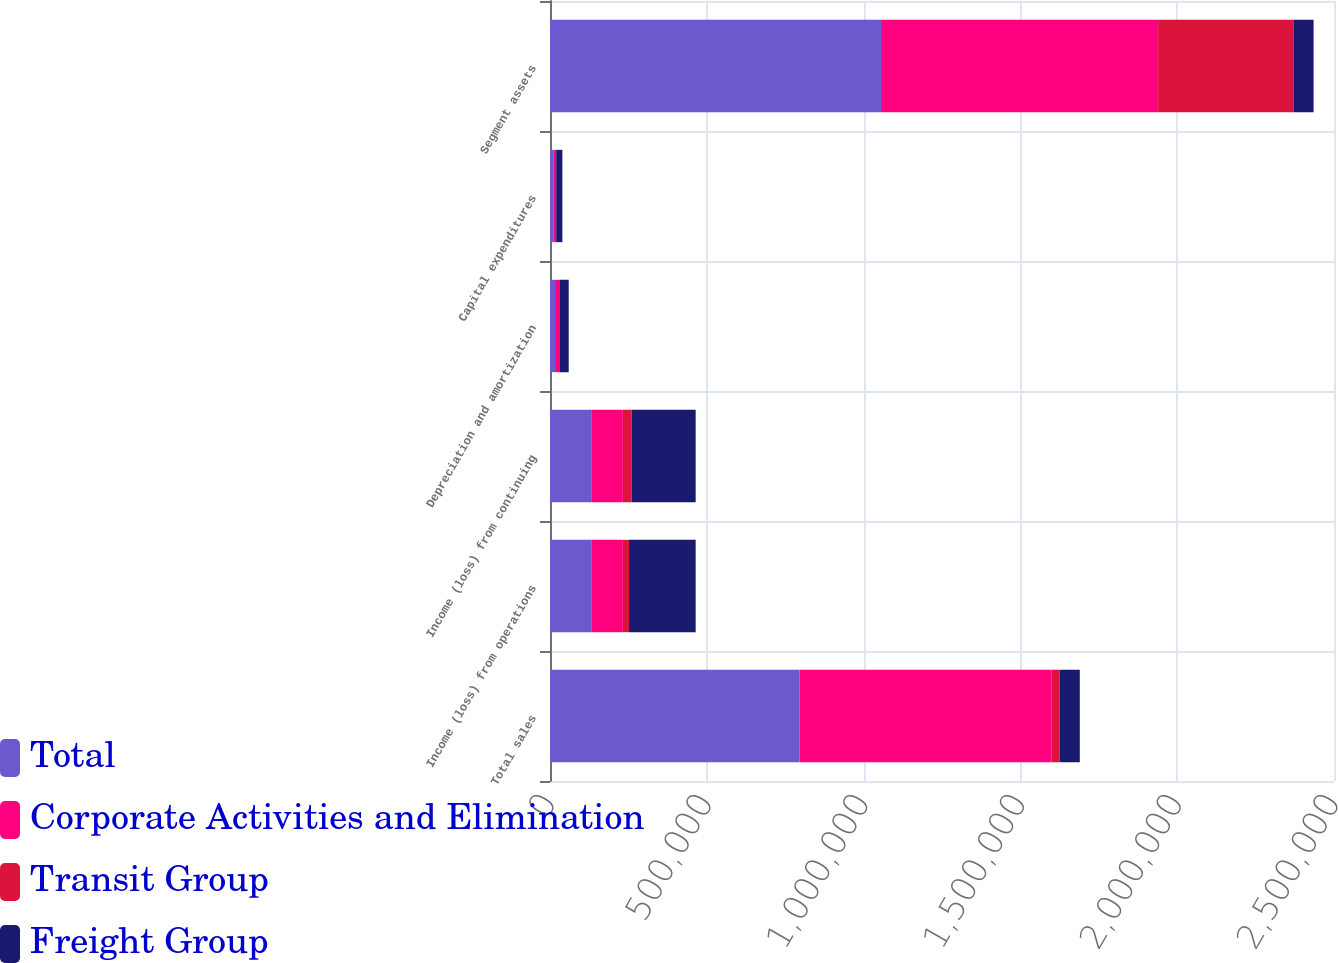<chart> <loc_0><loc_0><loc_500><loc_500><stacked_bar_chart><ecel><fcel>Total sales<fcel>Income (loss) from operations<fcel>Income (loss) from continuing<fcel>Depreciation and amortization<fcel>Capital expenditures<fcel>Segment assets<nl><fcel>Total<fcel>796081<fcel>133463<fcel>133463<fcel>16206<fcel>12178<fcel>1.05562e+06<nl><fcel>Corporate Activities and Elimination<fcel>803841<fcel>98792<fcel>98792<fcel>12916<fcel>7164<fcel>883440<nl><fcel>Transit Group<fcel>25173<fcel>19739<fcel>27955<fcel>704<fcel>373<fcel>431541<nl><fcel>Freight Group<fcel>64309<fcel>212516<fcel>204300<fcel>29826<fcel>19715<fcel>64309<nl></chart> 